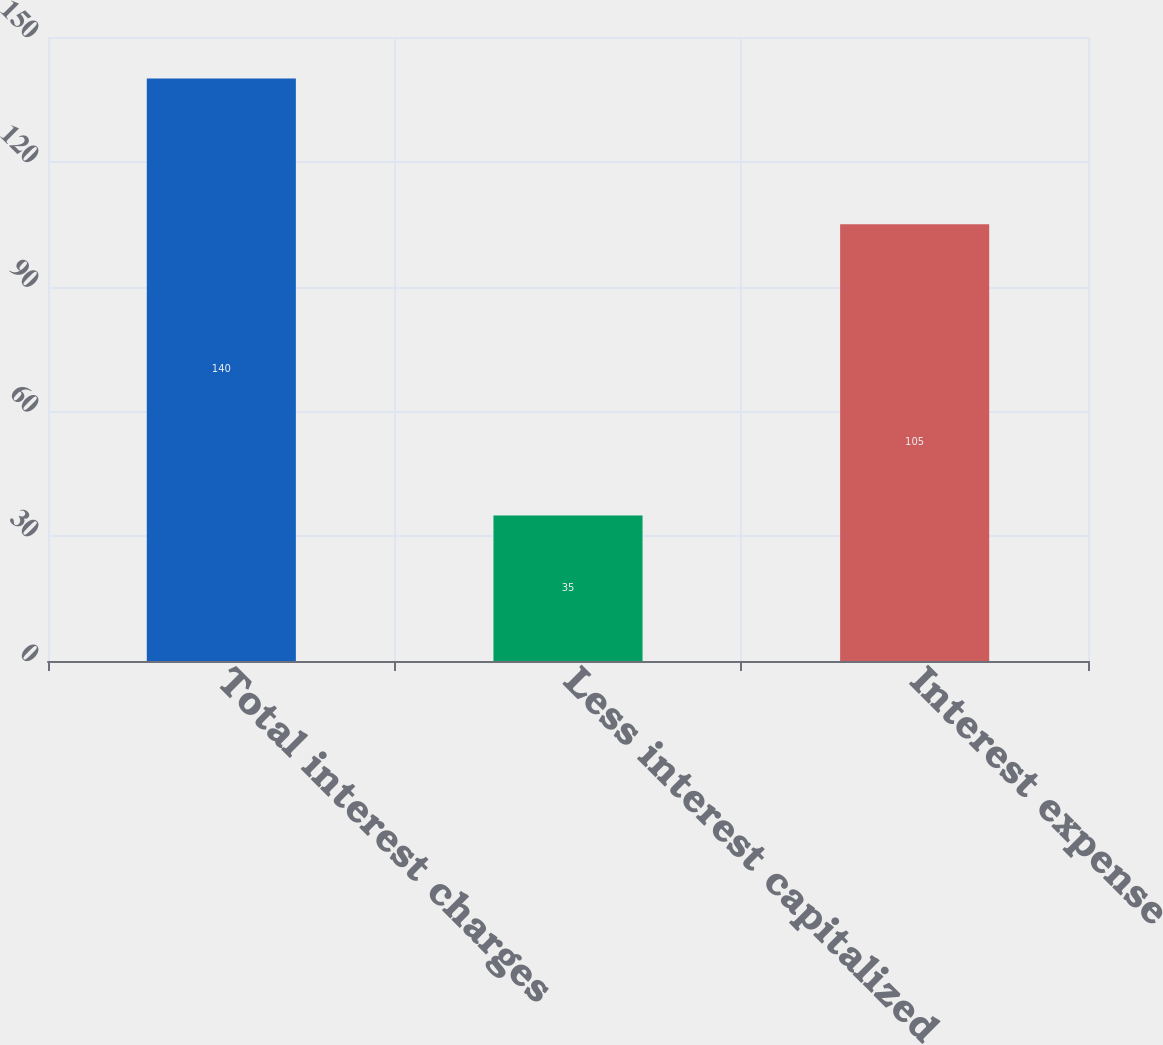Convert chart to OTSL. <chart><loc_0><loc_0><loc_500><loc_500><bar_chart><fcel>Total interest charges<fcel>Less interest capitalized<fcel>Interest expense<nl><fcel>140<fcel>35<fcel>105<nl></chart> 